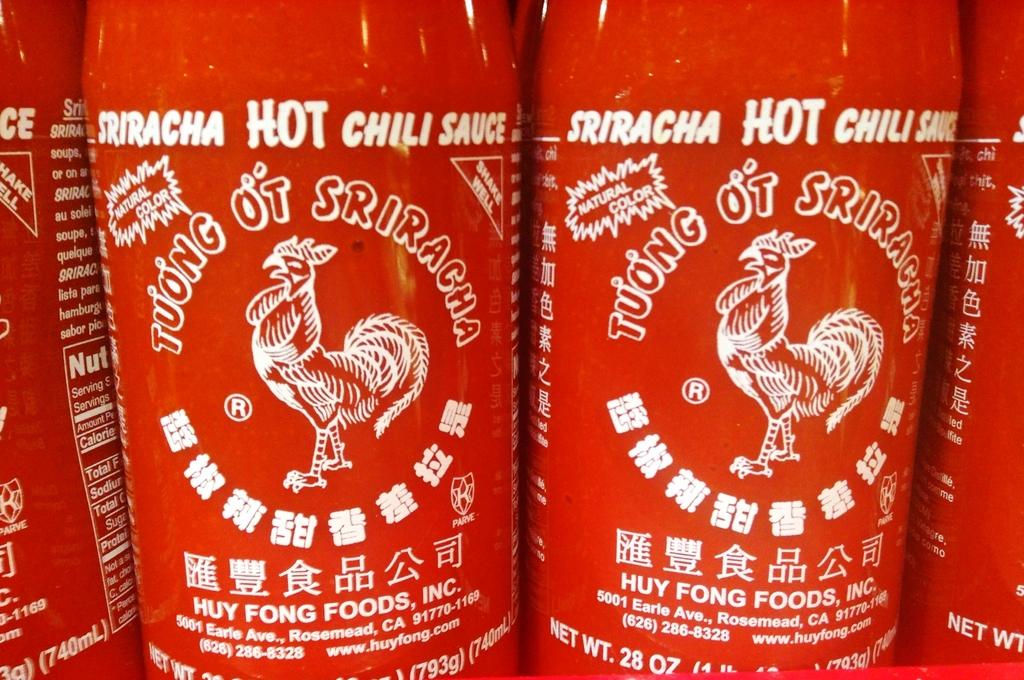What company makes the sauce?
Your answer should be compact. Huy fong foods, inc. 